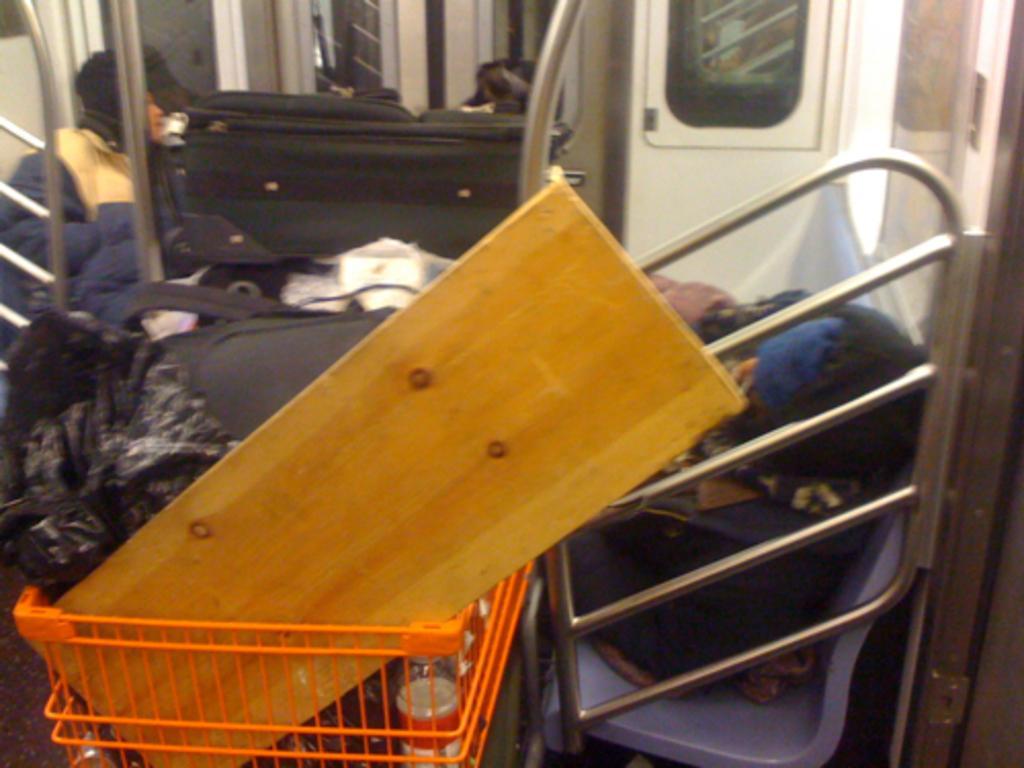Please provide a concise description of this image. This is the inside view of a metro train. Here we can see a wooden piece,water bottle and some other objects in the cart and we can also see luggage bags,two persons sitting on the seats,window,poles and doors. 